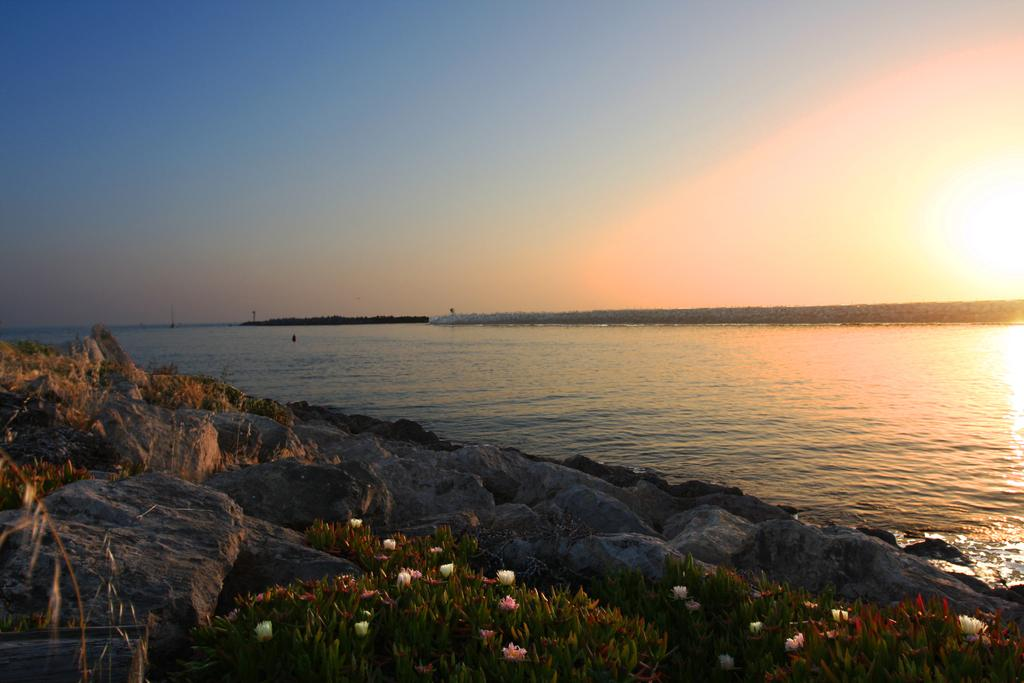What type of natural feature is present in the image? There is a river in the image. What can be seen at the bottom of the river? There are rocks and plants at the bottom of the image. What is visible at the top of the image? The sky is visible at the top of the image. Can you see a giraffe drinking from the river in the image? No, there are no giraffes present in the image. 